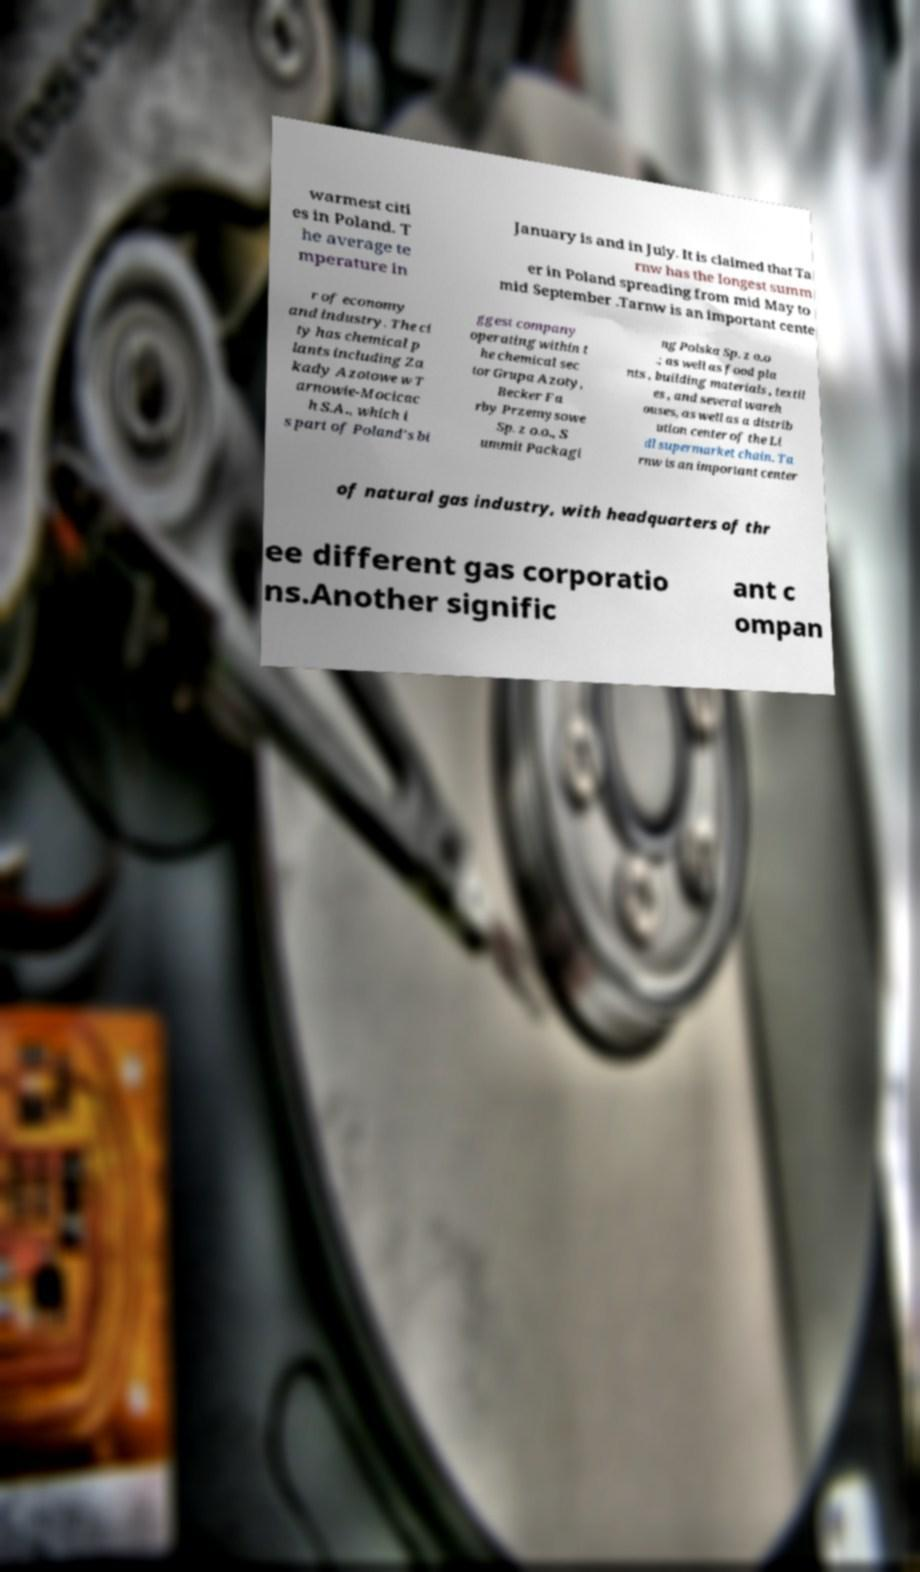For documentation purposes, I need the text within this image transcribed. Could you provide that? warmest citi es in Poland. T he average te mperature in January is and in July. It is claimed that Ta rnw has the longest summ er in Poland spreading from mid May to mid September .Tarnw is an important cente r of economy and industry. The ci ty has chemical p lants including Za kady Azotowe w T arnowie-Mocicac h S.A., which i s part of Poland's bi ggest company operating within t he chemical sec tor Grupa Azoty, Becker Fa rby Przemysowe Sp. z o.o., S ummit Packagi ng Polska Sp. z o.o .; as well as food pla nts , building materials , textil es , and several wareh ouses, as well as a distrib ution center of the Li dl supermarket chain. Ta rnw is an important center of natural gas industry, with headquarters of thr ee different gas corporatio ns.Another signific ant c ompan 